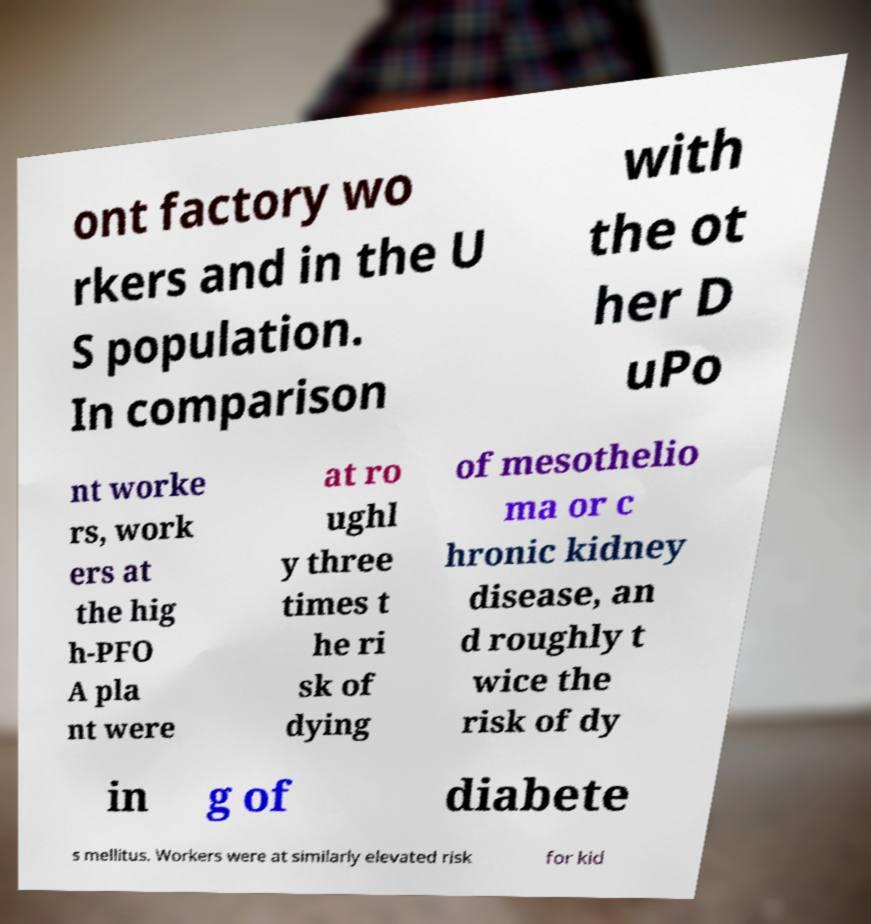Can you accurately transcribe the text from the provided image for me? ont factory wo rkers and in the U S population. In comparison with the ot her D uPo nt worke rs, work ers at the hig h-PFO A pla nt were at ro ughl y three times t he ri sk of dying of mesothelio ma or c hronic kidney disease, an d roughly t wice the risk of dy in g of diabete s mellitus. Workers were at similarly elevated risk for kid 